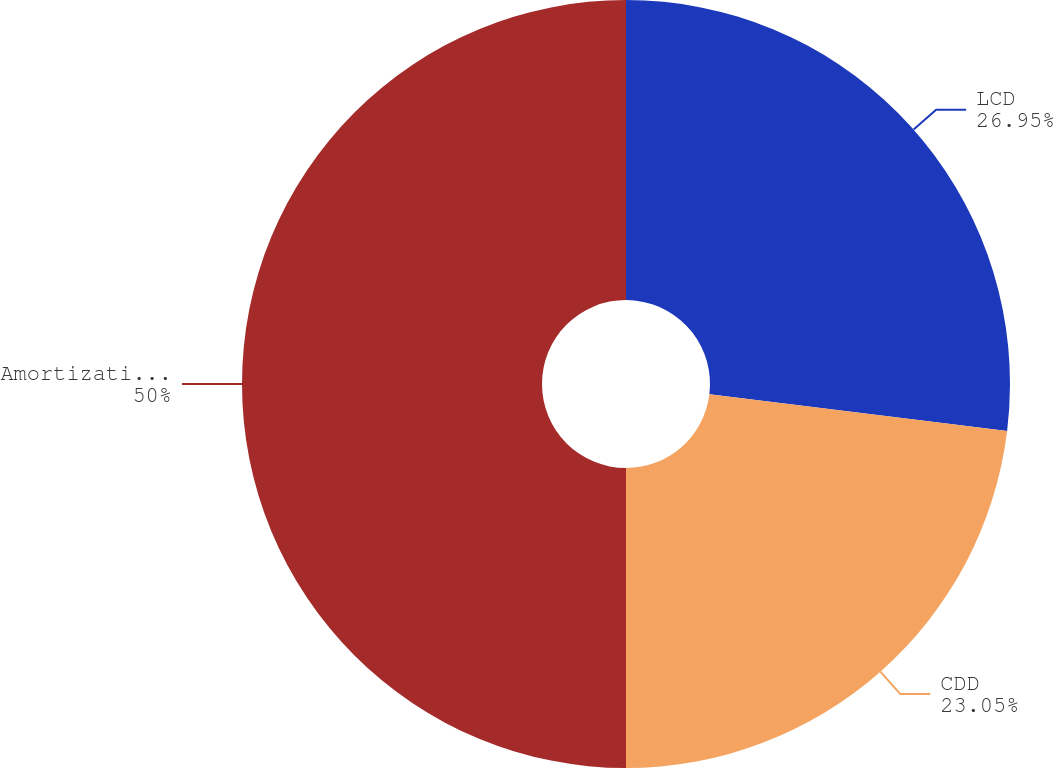<chart> <loc_0><loc_0><loc_500><loc_500><pie_chart><fcel>LCD<fcel>CDD<fcel>Amortization of intangibles<nl><fcel>26.95%<fcel>23.05%<fcel>50.0%<nl></chart> 